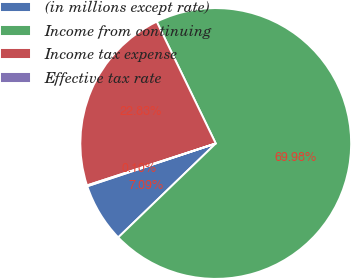<chart> <loc_0><loc_0><loc_500><loc_500><pie_chart><fcel>(in millions except rate)<fcel>Income from continuing<fcel>Income tax expense<fcel>Effective tax rate<nl><fcel>7.09%<fcel>69.98%<fcel>22.83%<fcel>0.1%<nl></chart> 